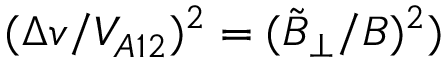Convert formula to latex. <formula><loc_0><loc_0><loc_500><loc_500>( \Delta v / V _ { A 1 2 } ) ^ { 2 } = ( \tilde { B } _ { \perp } / B ) ^ { 2 } )</formula> 